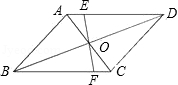Could line EF have any specific significance in the context of this diagram? Line EF, passing through the centroid O and extending across sides AD and BC, might be explored for properties such as bisecting those sides or having other relationships with the vertices or diagonals, which can be key in certain geometric proofs or constructions related to parallelograms. 